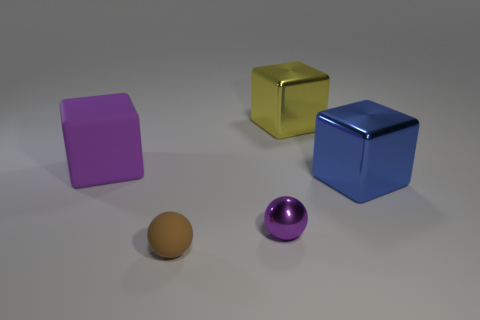Add 1 small blue metallic spheres. How many objects exist? 6 Subtract all balls. How many objects are left? 3 Add 3 gray spheres. How many gray spheres exist? 3 Subtract 0 cyan blocks. How many objects are left? 5 Subtract all big spheres. Subtract all brown balls. How many objects are left? 4 Add 3 large purple cubes. How many large purple cubes are left? 4 